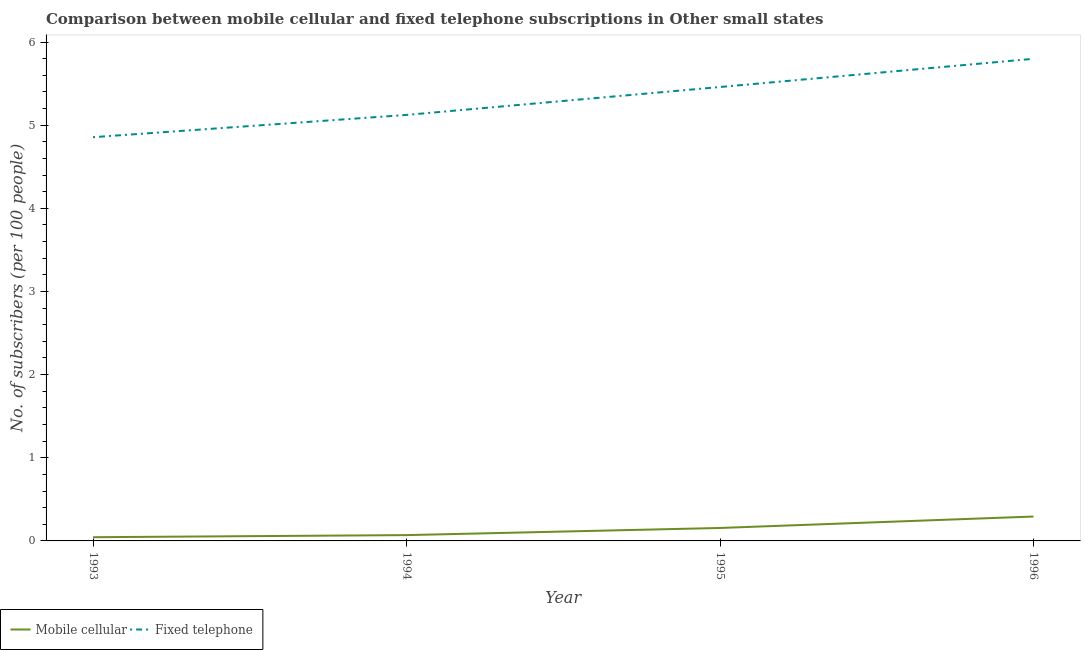How many different coloured lines are there?
Give a very brief answer. 2. What is the number of mobile cellular subscribers in 1993?
Offer a terse response. 0.04. Across all years, what is the maximum number of mobile cellular subscribers?
Provide a succinct answer. 0.29. Across all years, what is the minimum number of fixed telephone subscribers?
Offer a terse response. 4.86. In which year was the number of fixed telephone subscribers minimum?
Your answer should be very brief. 1993. What is the total number of fixed telephone subscribers in the graph?
Ensure brevity in your answer.  21.24. What is the difference between the number of fixed telephone subscribers in 1993 and that in 1995?
Your answer should be compact. -0.6. What is the difference between the number of mobile cellular subscribers in 1993 and the number of fixed telephone subscribers in 1994?
Your answer should be compact. -5.08. What is the average number of fixed telephone subscribers per year?
Provide a succinct answer. 5.31. In the year 1993, what is the difference between the number of fixed telephone subscribers and number of mobile cellular subscribers?
Give a very brief answer. 4.81. In how many years, is the number of fixed telephone subscribers greater than 4.2?
Your answer should be very brief. 4. What is the ratio of the number of fixed telephone subscribers in 1993 to that in 1996?
Offer a very short reply. 0.84. What is the difference between the highest and the second highest number of fixed telephone subscribers?
Offer a terse response. 0.34. What is the difference between the highest and the lowest number of fixed telephone subscribers?
Your answer should be very brief. 0.94. In how many years, is the number of fixed telephone subscribers greater than the average number of fixed telephone subscribers taken over all years?
Keep it short and to the point. 2. Is the sum of the number of fixed telephone subscribers in 1993 and 1995 greater than the maximum number of mobile cellular subscribers across all years?
Your response must be concise. Yes. Is the number of fixed telephone subscribers strictly greater than the number of mobile cellular subscribers over the years?
Keep it short and to the point. Yes. How many lines are there?
Provide a succinct answer. 2. How many years are there in the graph?
Provide a succinct answer. 4. What is the difference between two consecutive major ticks on the Y-axis?
Your answer should be very brief. 1. How many legend labels are there?
Offer a terse response. 2. What is the title of the graph?
Your answer should be compact. Comparison between mobile cellular and fixed telephone subscriptions in Other small states. What is the label or title of the Y-axis?
Provide a short and direct response. No. of subscribers (per 100 people). What is the No. of subscribers (per 100 people) of Mobile cellular in 1993?
Your answer should be compact. 0.04. What is the No. of subscribers (per 100 people) of Fixed telephone in 1993?
Make the answer very short. 4.86. What is the No. of subscribers (per 100 people) in Mobile cellular in 1994?
Ensure brevity in your answer.  0.07. What is the No. of subscribers (per 100 people) of Fixed telephone in 1994?
Your answer should be very brief. 5.12. What is the No. of subscribers (per 100 people) of Mobile cellular in 1995?
Your response must be concise. 0.16. What is the No. of subscribers (per 100 people) in Fixed telephone in 1995?
Make the answer very short. 5.46. What is the No. of subscribers (per 100 people) in Mobile cellular in 1996?
Give a very brief answer. 0.29. What is the No. of subscribers (per 100 people) of Fixed telephone in 1996?
Your answer should be compact. 5.8. Across all years, what is the maximum No. of subscribers (per 100 people) in Mobile cellular?
Keep it short and to the point. 0.29. Across all years, what is the maximum No. of subscribers (per 100 people) in Fixed telephone?
Keep it short and to the point. 5.8. Across all years, what is the minimum No. of subscribers (per 100 people) in Mobile cellular?
Ensure brevity in your answer.  0.04. Across all years, what is the minimum No. of subscribers (per 100 people) of Fixed telephone?
Provide a short and direct response. 4.86. What is the total No. of subscribers (per 100 people) in Mobile cellular in the graph?
Make the answer very short. 0.56. What is the total No. of subscribers (per 100 people) in Fixed telephone in the graph?
Give a very brief answer. 21.24. What is the difference between the No. of subscribers (per 100 people) of Mobile cellular in 1993 and that in 1994?
Provide a short and direct response. -0.03. What is the difference between the No. of subscribers (per 100 people) in Fixed telephone in 1993 and that in 1994?
Offer a very short reply. -0.27. What is the difference between the No. of subscribers (per 100 people) of Mobile cellular in 1993 and that in 1995?
Your answer should be very brief. -0.11. What is the difference between the No. of subscribers (per 100 people) of Fixed telephone in 1993 and that in 1995?
Give a very brief answer. -0.6. What is the difference between the No. of subscribers (per 100 people) in Mobile cellular in 1993 and that in 1996?
Your answer should be very brief. -0.25. What is the difference between the No. of subscribers (per 100 people) of Fixed telephone in 1993 and that in 1996?
Your response must be concise. -0.94. What is the difference between the No. of subscribers (per 100 people) of Mobile cellular in 1994 and that in 1995?
Ensure brevity in your answer.  -0.09. What is the difference between the No. of subscribers (per 100 people) in Fixed telephone in 1994 and that in 1995?
Provide a succinct answer. -0.34. What is the difference between the No. of subscribers (per 100 people) in Mobile cellular in 1994 and that in 1996?
Provide a succinct answer. -0.22. What is the difference between the No. of subscribers (per 100 people) in Fixed telephone in 1994 and that in 1996?
Keep it short and to the point. -0.68. What is the difference between the No. of subscribers (per 100 people) in Mobile cellular in 1995 and that in 1996?
Keep it short and to the point. -0.14. What is the difference between the No. of subscribers (per 100 people) in Fixed telephone in 1995 and that in 1996?
Your answer should be very brief. -0.34. What is the difference between the No. of subscribers (per 100 people) of Mobile cellular in 1993 and the No. of subscribers (per 100 people) of Fixed telephone in 1994?
Give a very brief answer. -5.08. What is the difference between the No. of subscribers (per 100 people) of Mobile cellular in 1993 and the No. of subscribers (per 100 people) of Fixed telephone in 1995?
Give a very brief answer. -5.41. What is the difference between the No. of subscribers (per 100 people) of Mobile cellular in 1993 and the No. of subscribers (per 100 people) of Fixed telephone in 1996?
Your answer should be very brief. -5.75. What is the difference between the No. of subscribers (per 100 people) of Mobile cellular in 1994 and the No. of subscribers (per 100 people) of Fixed telephone in 1995?
Provide a succinct answer. -5.39. What is the difference between the No. of subscribers (per 100 people) in Mobile cellular in 1994 and the No. of subscribers (per 100 people) in Fixed telephone in 1996?
Ensure brevity in your answer.  -5.73. What is the difference between the No. of subscribers (per 100 people) in Mobile cellular in 1995 and the No. of subscribers (per 100 people) in Fixed telephone in 1996?
Ensure brevity in your answer.  -5.64. What is the average No. of subscribers (per 100 people) of Mobile cellular per year?
Your answer should be very brief. 0.14. What is the average No. of subscribers (per 100 people) in Fixed telephone per year?
Your response must be concise. 5.31. In the year 1993, what is the difference between the No. of subscribers (per 100 people) in Mobile cellular and No. of subscribers (per 100 people) in Fixed telephone?
Provide a succinct answer. -4.81. In the year 1994, what is the difference between the No. of subscribers (per 100 people) of Mobile cellular and No. of subscribers (per 100 people) of Fixed telephone?
Provide a short and direct response. -5.05. In the year 1995, what is the difference between the No. of subscribers (per 100 people) in Mobile cellular and No. of subscribers (per 100 people) in Fixed telephone?
Give a very brief answer. -5.3. In the year 1996, what is the difference between the No. of subscribers (per 100 people) of Mobile cellular and No. of subscribers (per 100 people) of Fixed telephone?
Ensure brevity in your answer.  -5.51. What is the ratio of the No. of subscribers (per 100 people) of Mobile cellular in 1993 to that in 1994?
Provide a succinct answer. 0.64. What is the ratio of the No. of subscribers (per 100 people) of Fixed telephone in 1993 to that in 1994?
Make the answer very short. 0.95. What is the ratio of the No. of subscribers (per 100 people) in Mobile cellular in 1993 to that in 1995?
Your response must be concise. 0.29. What is the ratio of the No. of subscribers (per 100 people) in Fixed telephone in 1993 to that in 1995?
Give a very brief answer. 0.89. What is the ratio of the No. of subscribers (per 100 people) of Mobile cellular in 1993 to that in 1996?
Your answer should be very brief. 0.15. What is the ratio of the No. of subscribers (per 100 people) of Fixed telephone in 1993 to that in 1996?
Keep it short and to the point. 0.84. What is the ratio of the No. of subscribers (per 100 people) in Mobile cellular in 1994 to that in 1995?
Offer a very short reply. 0.45. What is the ratio of the No. of subscribers (per 100 people) of Fixed telephone in 1994 to that in 1995?
Provide a short and direct response. 0.94. What is the ratio of the No. of subscribers (per 100 people) of Mobile cellular in 1994 to that in 1996?
Make the answer very short. 0.24. What is the ratio of the No. of subscribers (per 100 people) in Fixed telephone in 1994 to that in 1996?
Provide a succinct answer. 0.88. What is the ratio of the No. of subscribers (per 100 people) of Mobile cellular in 1995 to that in 1996?
Offer a very short reply. 0.53. What is the ratio of the No. of subscribers (per 100 people) of Fixed telephone in 1995 to that in 1996?
Offer a terse response. 0.94. What is the difference between the highest and the second highest No. of subscribers (per 100 people) of Mobile cellular?
Provide a short and direct response. 0.14. What is the difference between the highest and the second highest No. of subscribers (per 100 people) in Fixed telephone?
Your response must be concise. 0.34. What is the difference between the highest and the lowest No. of subscribers (per 100 people) in Mobile cellular?
Your answer should be very brief. 0.25. What is the difference between the highest and the lowest No. of subscribers (per 100 people) in Fixed telephone?
Offer a terse response. 0.94. 